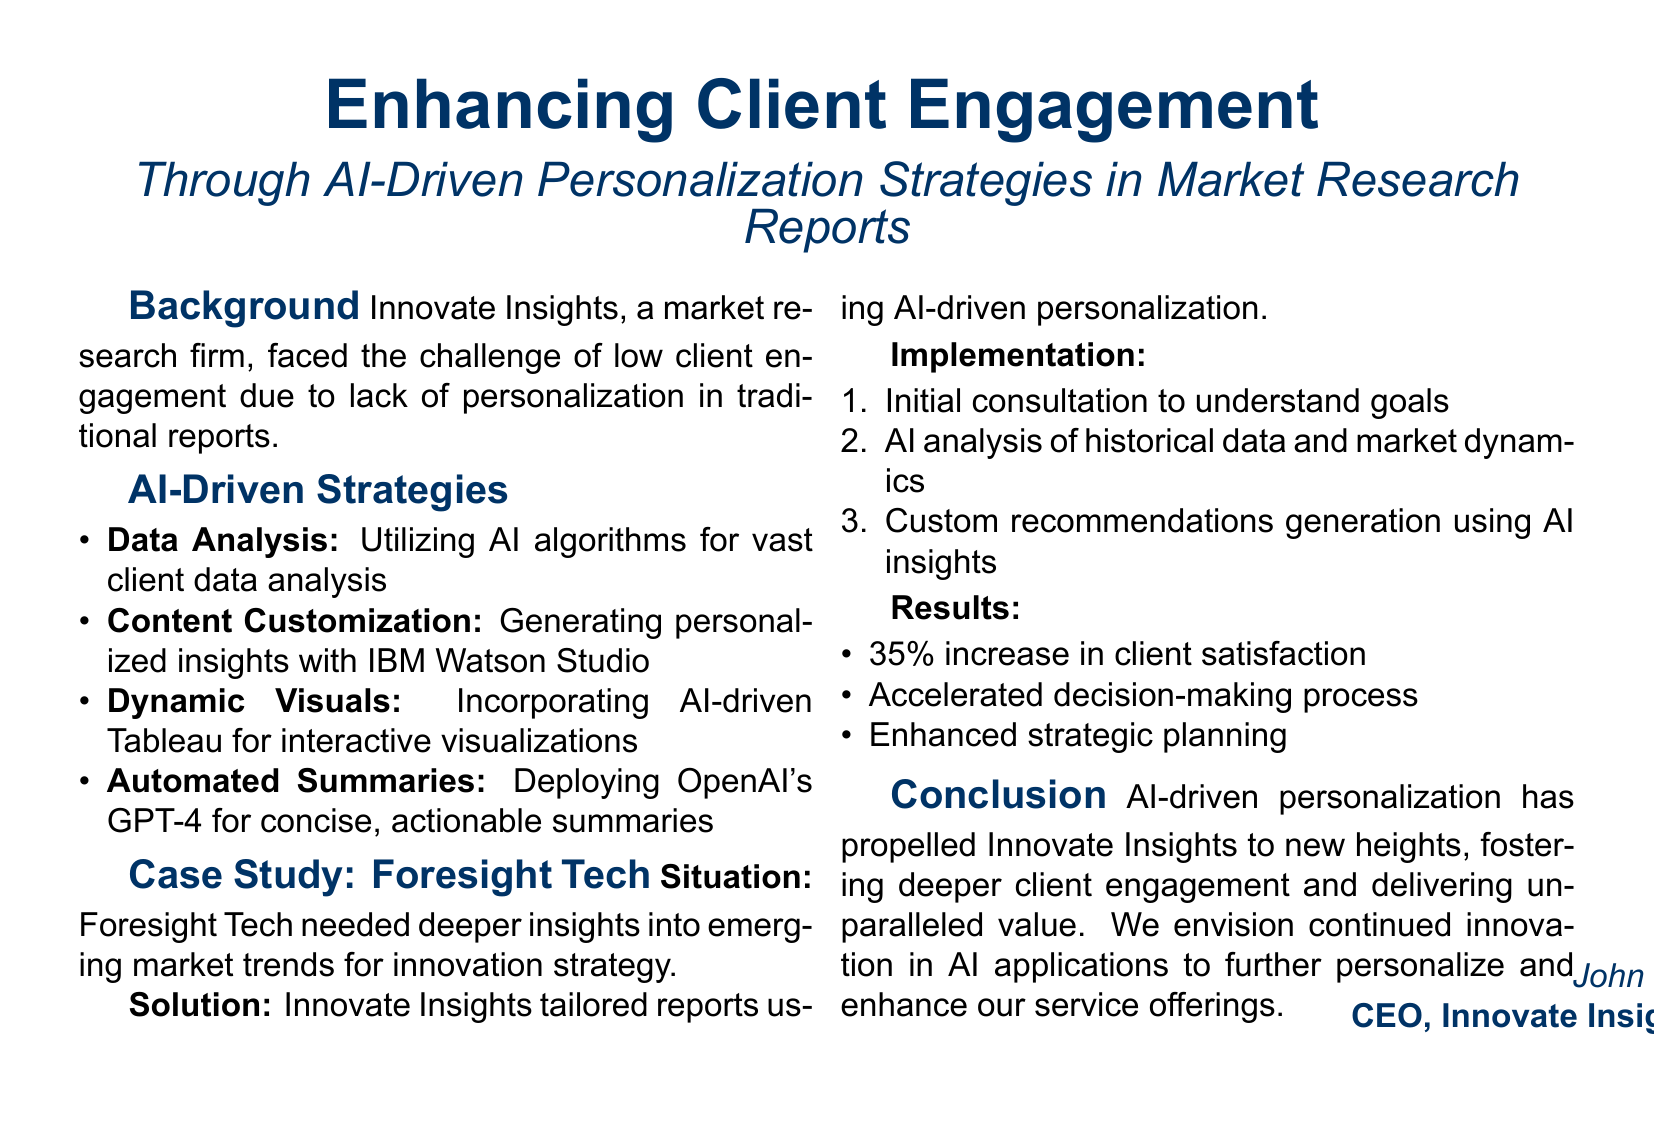What is the name of the market research firm in the case study? The document identifies the market research firm as Innovate Insights.
Answer: Innovate Insights What technology was used for content customization? The document states that IBM Watson Studio was used for content customization.
Answer: IBM Watson Studio By what percentage did client satisfaction increase? The document specifies that there was a 35% increase in client satisfaction.
Answer: 35% What was the first step in the implementation process? The document mentions that the initial consultation to understand goals was the first step.
Answer: Initial consultation What is the outcome of AI-driven personalization according to the conclusion? The document concludes that AI-driven personalization has fostered deeper client engagement.
Answer: Deeper client engagement Which company was the case study focused on? The document indicates that the case study focused on Foresight Tech.
Answer: Foresight Tech What type of visuals were integrated into the reports? The document refers to AI-driven Tableau for interactive visualizations.
Answer: Interactive visualizations What was one of the results achieved besides increased client satisfaction? The document lists accelerated decision-making process as a result achieved.
Answer: Accelerated decision-making process 